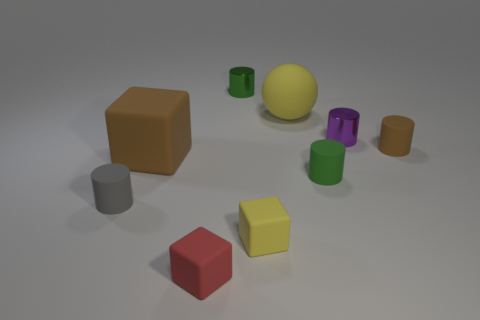Subtract 2 cylinders. How many cylinders are left? 3 Subtract all purple cylinders. How many cylinders are left? 4 Subtract all cyan cylinders. Subtract all brown balls. How many cylinders are left? 5 Subtract all cubes. How many objects are left? 6 Add 3 small brown cylinders. How many small brown cylinders exist? 4 Subtract 0 blue blocks. How many objects are left? 9 Subtract all big yellow rubber blocks. Subtract all tiny gray matte things. How many objects are left? 8 Add 5 green metallic things. How many green metallic things are left? 6 